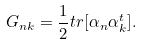Convert formula to latex. <formula><loc_0><loc_0><loc_500><loc_500>G _ { n k } = \frac { 1 } { 2 } t r [ \alpha _ { n } \alpha _ { k } ^ { t } ] .</formula> 